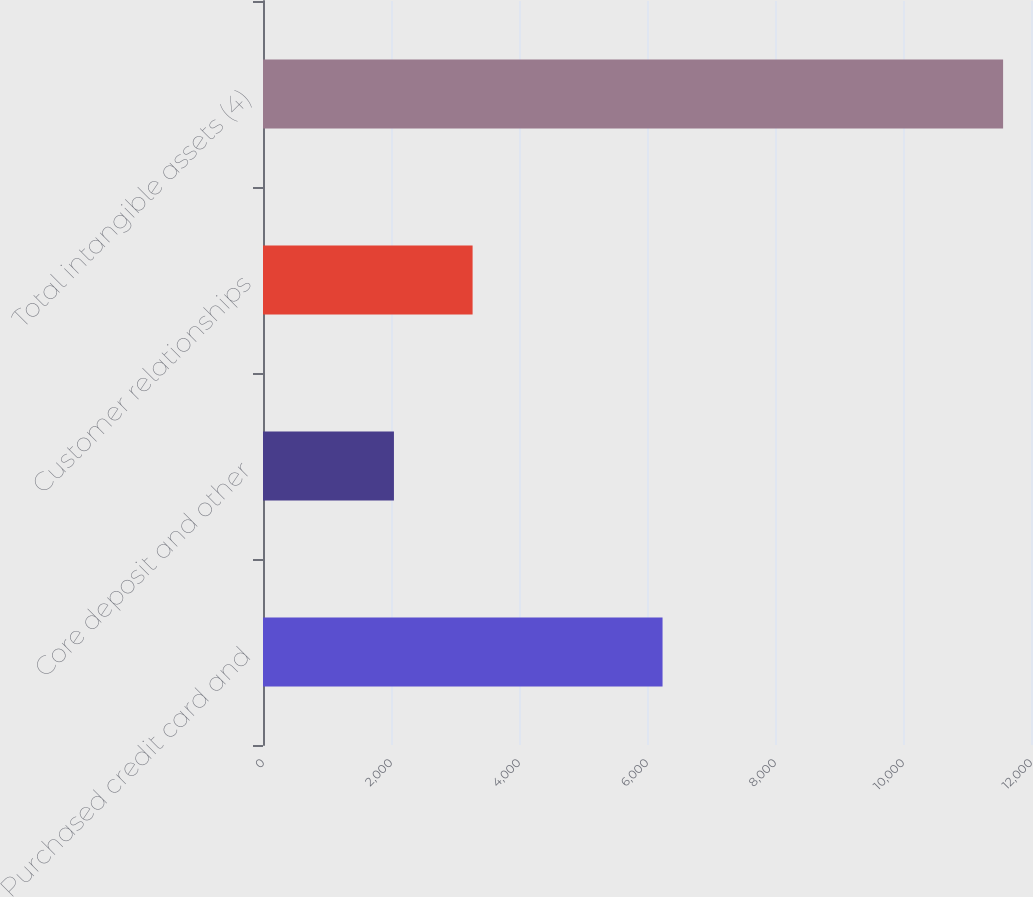<chart> <loc_0><loc_0><loc_500><loc_500><bar_chart><fcel>Purchased credit card and<fcel>Core deposit and other<fcel>Customer relationships<fcel>Total intangible assets (4)<nl><fcel>6243<fcel>2046<fcel>3275<fcel>11564<nl></chart> 